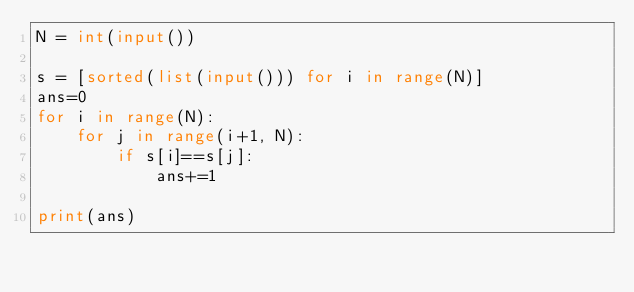Convert code to text. <code><loc_0><loc_0><loc_500><loc_500><_Python_>N = int(input())

s = [sorted(list(input())) for i in range(N)]
ans=0
for i in range(N):
    for j in range(i+1, N):
        if s[i]==s[j]:
            ans+=1

print(ans)
</code> 